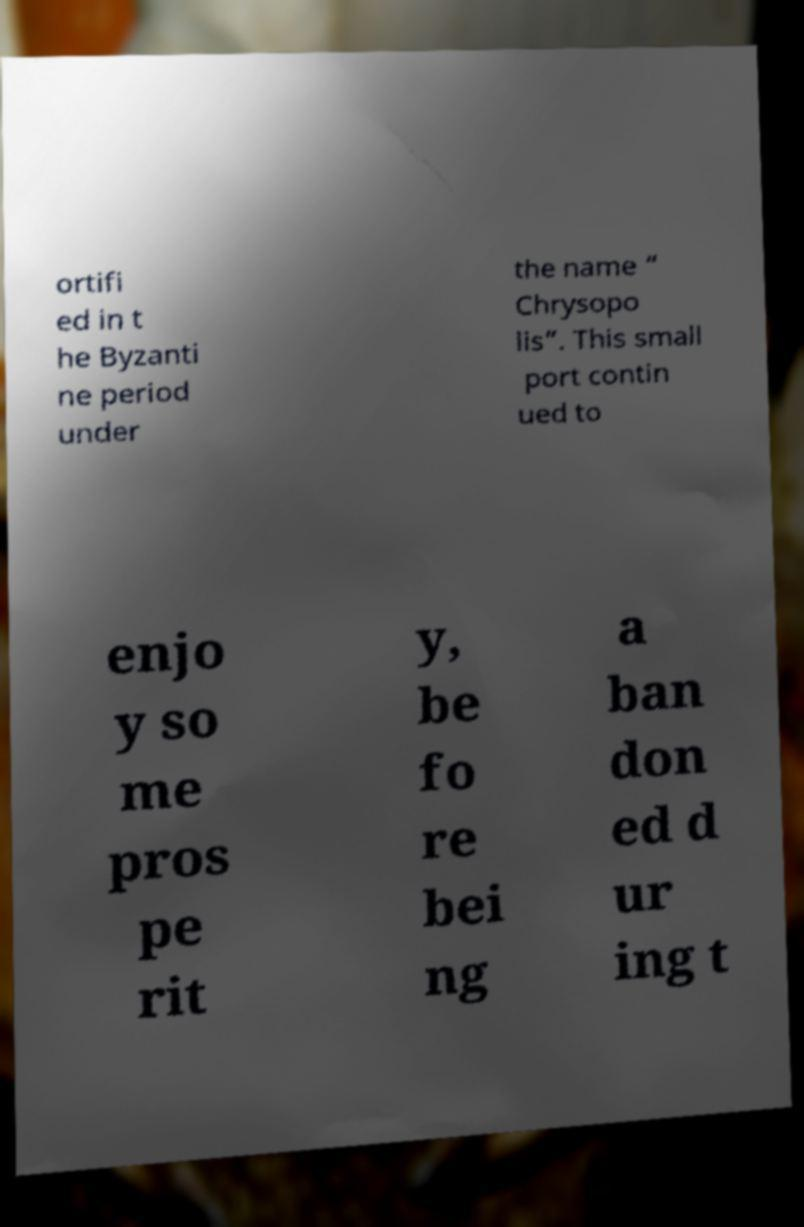What messages or text are displayed in this image? I need them in a readable, typed format. ortifi ed in t he Byzanti ne period under the name “ Chrysopo lis”. This small port contin ued to enjo y so me pros pe rit y, be fo re bei ng a ban don ed d ur ing t 